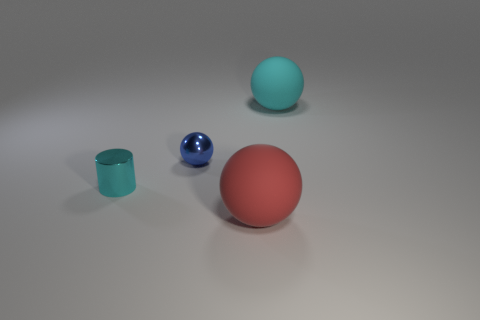Add 4 cyan metallic objects. How many objects exist? 8 Subtract all spheres. How many objects are left? 1 Subtract 1 blue balls. How many objects are left? 3 Subtract all big blue blocks. Subtract all cyan rubber spheres. How many objects are left? 3 Add 3 cyan balls. How many cyan balls are left? 4 Add 3 large matte objects. How many large matte objects exist? 5 